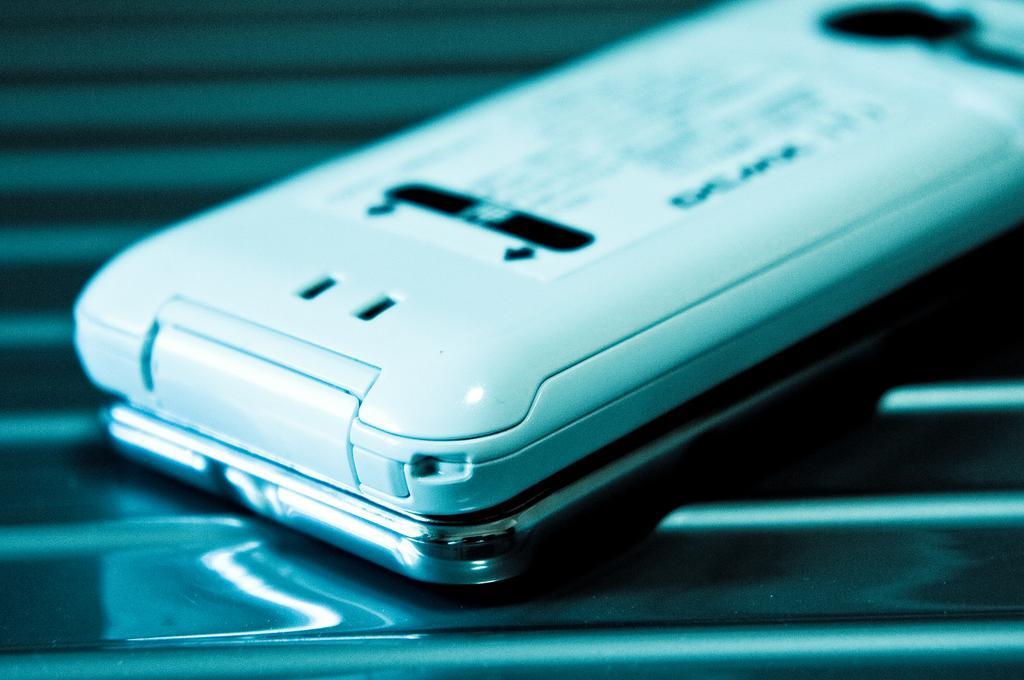Please provide a concise description of this image. In this picture we can see a mobile phone in the front, there is a blurry background, there is a paper pasted to the mobile. 